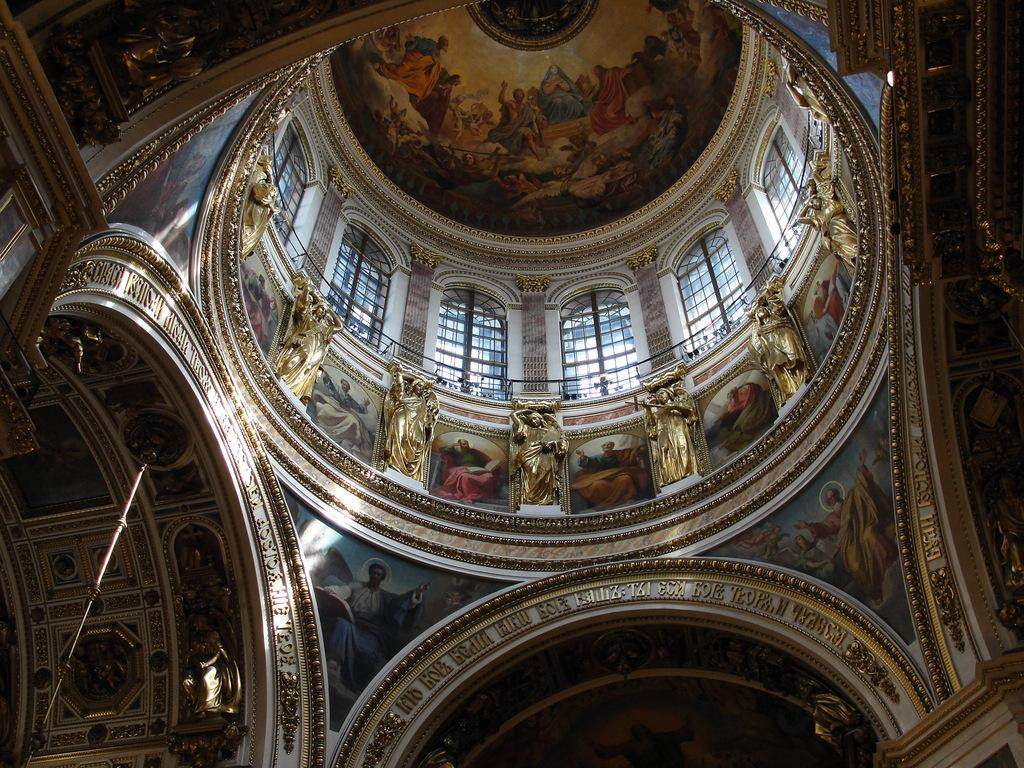What type of location is depicted in the image? The image shows an inside view of a building. What can be seen in the center of the image? There are sculptures in the center of the image. What architectural feature is visible in the background? There are windows visible in the background. What type of art is present on the ceiling in the background? There is art on the ceiling in the background. What month is depicted in the art on the ceiling? The image does not show a specific month; it only shows art on the ceiling. How does the art on the ceiling show respect for the building's history? The image does not provide any information about the art's meaning or purpose, so we cannot determine if it shows respect for the building's history. 